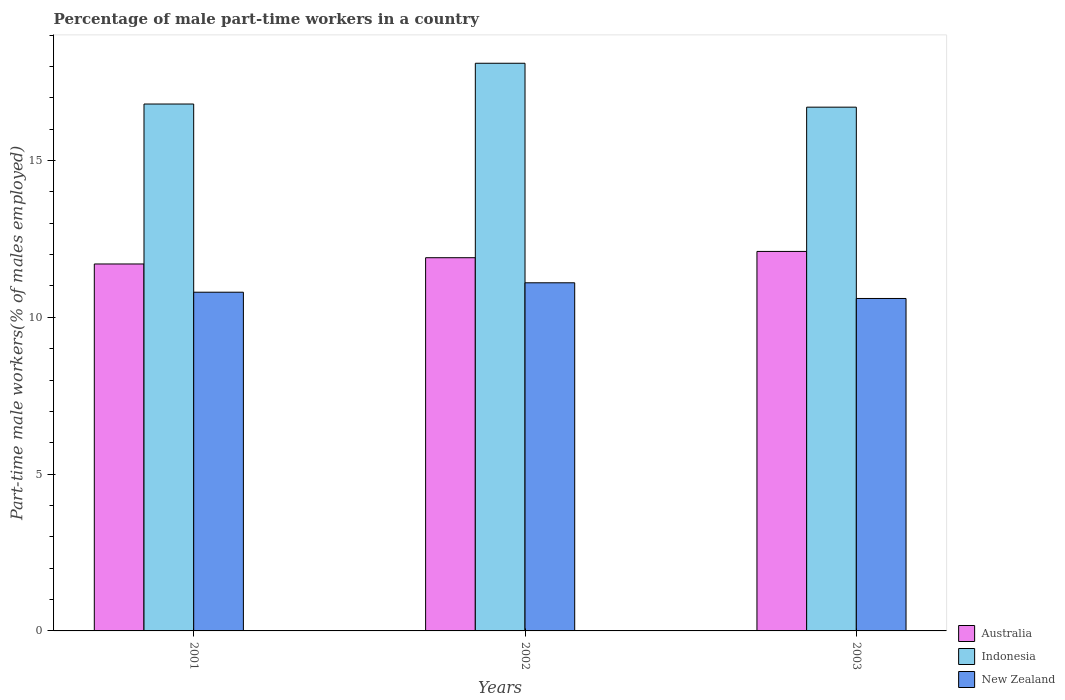How many groups of bars are there?
Ensure brevity in your answer.  3. Are the number of bars per tick equal to the number of legend labels?
Your response must be concise. Yes. Are the number of bars on each tick of the X-axis equal?
Offer a very short reply. Yes. How many bars are there on the 1st tick from the left?
Your response must be concise. 3. What is the percentage of male part-time workers in New Zealand in 2003?
Provide a succinct answer. 10.6. Across all years, what is the maximum percentage of male part-time workers in Australia?
Offer a very short reply. 12.1. Across all years, what is the minimum percentage of male part-time workers in Indonesia?
Your response must be concise. 16.7. In which year was the percentage of male part-time workers in Indonesia minimum?
Offer a very short reply. 2003. What is the total percentage of male part-time workers in Australia in the graph?
Provide a short and direct response. 35.7. What is the difference between the percentage of male part-time workers in Indonesia in 2002 and that in 2003?
Provide a short and direct response. 1.4. What is the difference between the percentage of male part-time workers in Australia in 2001 and the percentage of male part-time workers in New Zealand in 2002?
Provide a short and direct response. 0.6. What is the average percentage of male part-time workers in Indonesia per year?
Your response must be concise. 17.2. In the year 2003, what is the difference between the percentage of male part-time workers in Indonesia and percentage of male part-time workers in New Zealand?
Your answer should be compact. 6.1. What is the ratio of the percentage of male part-time workers in Indonesia in 2002 to that in 2003?
Offer a terse response. 1.08. Is the percentage of male part-time workers in Australia in 2001 less than that in 2002?
Keep it short and to the point. Yes. Is the difference between the percentage of male part-time workers in Indonesia in 2001 and 2002 greater than the difference between the percentage of male part-time workers in New Zealand in 2001 and 2002?
Offer a very short reply. No. What is the difference between the highest and the second highest percentage of male part-time workers in Australia?
Provide a short and direct response. 0.2. What is the difference between the highest and the lowest percentage of male part-time workers in New Zealand?
Make the answer very short. 0.5. Is the sum of the percentage of male part-time workers in Indonesia in 2001 and 2003 greater than the maximum percentage of male part-time workers in Australia across all years?
Give a very brief answer. Yes. What does the 3rd bar from the left in 2002 represents?
Ensure brevity in your answer.  New Zealand. What does the 1st bar from the right in 2001 represents?
Provide a succinct answer. New Zealand. Is it the case that in every year, the sum of the percentage of male part-time workers in Indonesia and percentage of male part-time workers in New Zealand is greater than the percentage of male part-time workers in Australia?
Provide a short and direct response. Yes. Are the values on the major ticks of Y-axis written in scientific E-notation?
Ensure brevity in your answer.  No. Does the graph contain any zero values?
Ensure brevity in your answer.  No. Does the graph contain grids?
Offer a very short reply. No. Where does the legend appear in the graph?
Your response must be concise. Bottom right. What is the title of the graph?
Ensure brevity in your answer.  Percentage of male part-time workers in a country. What is the label or title of the X-axis?
Your answer should be compact. Years. What is the label or title of the Y-axis?
Offer a very short reply. Part-time male workers(% of males employed). What is the Part-time male workers(% of males employed) in Australia in 2001?
Offer a very short reply. 11.7. What is the Part-time male workers(% of males employed) of Indonesia in 2001?
Give a very brief answer. 16.8. What is the Part-time male workers(% of males employed) of New Zealand in 2001?
Ensure brevity in your answer.  10.8. What is the Part-time male workers(% of males employed) in Australia in 2002?
Give a very brief answer. 11.9. What is the Part-time male workers(% of males employed) of Indonesia in 2002?
Offer a very short reply. 18.1. What is the Part-time male workers(% of males employed) of New Zealand in 2002?
Offer a terse response. 11.1. What is the Part-time male workers(% of males employed) in Australia in 2003?
Your answer should be compact. 12.1. What is the Part-time male workers(% of males employed) of Indonesia in 2003?
Your answer should be very brief. 16.7. What is the Part-time male workers(% of males employed) of New Zealand in 2003?
Give a very brief answer. 10.6. Across all years, what is the maximum Part-time male workers(% of males employed) of Australia?
Give a very brief answer. 12.1. Across all years, what is the maximum Part-time male workers(% of males employed) of Indonesia?
Ensure brevity in your answer.  18.1. Across all years, what is the maximum Part-time male workers(% of males employed) of New Zealand?
Your answer should be compact. 11.1. Across all years, what is the minimum Part-time male workers(% of males employed) of Australia?
Make the answer very short. 11.7. Across all years, what is the minimum Part-time male workers(% of males employed) of Indonesia?
Your answer should be very brief. 16.7. Across all years, what is the minimum Part-time male workers(% of males employed) in New Zealand?
Provide a succinct answer. 10.6. What is the total Part-time male workers(% of males employed) of Australia in the graph?
Ensure brevity in your answer.  35.7. What is the total Part-time male workers(% of males employed) in Indonesia in the graph?
Your answer should be compact. 51.6. What is the total Part-time male workers(% of males employed) of New Zealand in the graph?
Your answer should be very brief. 32.5. What is the difference between the Part-time male workers(% of males employed) in Australia in 2001 and that in 2002?
Ensure brevity in your answer.  -0.2. What is the difference between the Part-time male workers(% of males employed) of New Zealand in 2001 and that in 2002?
Offer a terse response. -0.3. What is the difference between the Part-time male workers(% of males employed) of Australia in 2001 and that in 2003?
Provide a short and direct response. -0.4. What is the difference between the Part-time male workers(% of males employed) of Indonesia in 2001 and that in 2003?
Make the answer very short. 0.1. What is the difference between the Part-time male workers(% of males employed) in New Zealand in 2001 and that in 2003?
Your response must be concise. 0.2. What is the difference between the Part-time male workers(% of males employed) of Australia in 2001 and the Part-time male workers(% of males employed) of Indonesia in 2002?
Your answer should be very brief. -6.4. What is the difference between the Part-time male workers(% of males employed) of Australia in 2001 and the Part-time male workers(% of males employed) of New Zealand in 2002?
Provide a short and direct response. 0.6. What is the difference between the Part-time male workers(% of males employed) in Indonesia in 2001 and the Part-time male workers(% of males employed) in New Zealand in 2002?
Give a very brief answer. 5.7. What is the difference between the Part-time male workers(% of males employed) of Australia in 2001 and the Part-time male workers(% of males employed) of New Zealand in 2003?
Your response must be concise. 1.1. What is the difference between the Part-time male workers(% of males employed) in Australia in 2002 and the Part-time male workers(% of males employed) in New Zealand in 2003?
Provide a short and direct response. 1.3. What is the average Part-time male workers(% of males employed) of Australia per year?
Ensure brevity in your answer.  11.9. What is the average Part-time male workers(% of males employed) in Indonesia per year?
Your response must be concise. 17.2. What is the average Part-time male workers(% of males employed) in New Zealand per year?
Your answer should be very brief. 10.83. In the year 2001, what is the difference between the Part-time male workers(% of males employed) of Australia and Part-time male workers(% of males employed) of New Zealand?
Offer a very short reply. 0.9. In the year 2002, what is the difference between the Part-time male workers(% of males employed) in Australia and Part-time male workers(% of males employed) in Indonesia?
Offer a very short reply. -6.2. In the year 2002, what is the difference between the Part-time male workers(% of males employed) in Australia and Part-time male workers(% of males employed) in New Zealand?
Make the answer very short. 0.8. In the year 2003, what is the difference between the Part-time male workers(% of males employed) of Australia and Part-time male workers(% of males employed) of Indonesia?
Make the answer very short. -4.6. In the year 2003, what is the difference between the Part-time male workers(% of males employed) in Australia and Part-time male workers(% of males employed) in New Zealand?
Your answer should be compact. 1.5. In the year 2003, what is the difference between the Part-time male workers(% of males employed) in Indonesia and Part-time male workers(% of males employed) in New Zealand?
Offer a terse response. 6.1. What is the ratio of the Part-time male workers(% of males employed) in Australia in 2001 to that in 2002?
Offer a terse response. 0.98. What is the ratio of the Part-time male workers(% of males employed) in Indonesia in 2001 to that in 2002?
Provide a succinct answer. 0.93. What is the ratio of the Part-time male workers(% of males employed) of New Zealand in 2001 to that in 2002?
Offer a terse response. 0.97. What is the ratio of the Part-time male workers(% of males employed) of Australia in 2001 to that in 2003?
Your answer should be compact. 0.97. What is the ratio of the Part-time male workers(% of males employed) in New Zealand in 2001 to that in 2003?
Offer a very short reply. 1.02. What is the ratio of the Part-time male workers(% of males employed) of Australia in 2002 to that in 2003?
Give a very brief answer. 0.98. What is the ratio of the Part-time male workers(% of males employed) in Indonesia in 2002 to that in 2003?
Ensure brevity in your answer.  1.08. What is the ratio of the Part-time male workers(% of males employed) in New Zealand in 2002 to that in 2003?
Ensure brevity in your answer.  1.05. What is the difference between the highest and the second highest Part-time male workers(% of males employed) in Australia?
Your response must be concise. 0.2. What is the difference between the highest and the second highest Part-time male workers(% of males employed) in Indonesia?
Offer a very short reply. 1.3. What is the difference between the highest and the second highest Part-time male workers(% of males employed) in New Zealand?
Offer a terse response. 0.3. What is the difference between the highest and the lowest Part-time male workers(% of males employed) in Australia?
Offer a very short reply. 0.4. What is the difference between the highest and the lowest Part-time male workers(% of males employed) in Indonesia?
Give a very brief answer. 1.4. 